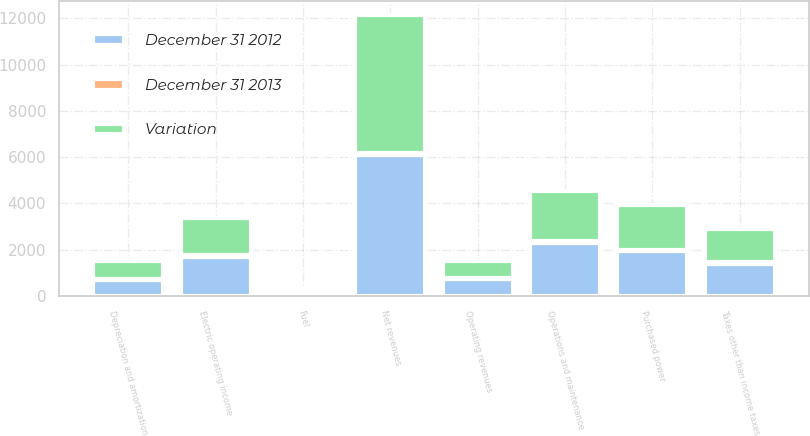<chart> <loc_0><loc_0><loc_500><loc_500><stacked_bar_chart><ecel><fcel>Operating revenues<fcel>Purchased power<fcel>Fuel<fcel>Net revenues<fcel>Operations and maintenance<fcel>Depreciation and amortization<fcel>Taxes other than income taxes<fcel>Electric operating income<nl><fcel>Variation<fcel>729.5<fcel>1974<fcel>174<fcel>5983<fcel>2180<fcel>749<fcel>1459<fcel>1595<nl><fcel>December 31 2012<fcel>729.5<fcel>1938<fcel>159<fcel>6079<fcel>2273<fcel>710<fcel>1403<fcel>1693<nl><fcel>December 31 2013<fcel>45<fcel>36<fcel>15<fcel>96<fcel>93<fcel>39<fcel>56<fcel>98<nl></chart> 